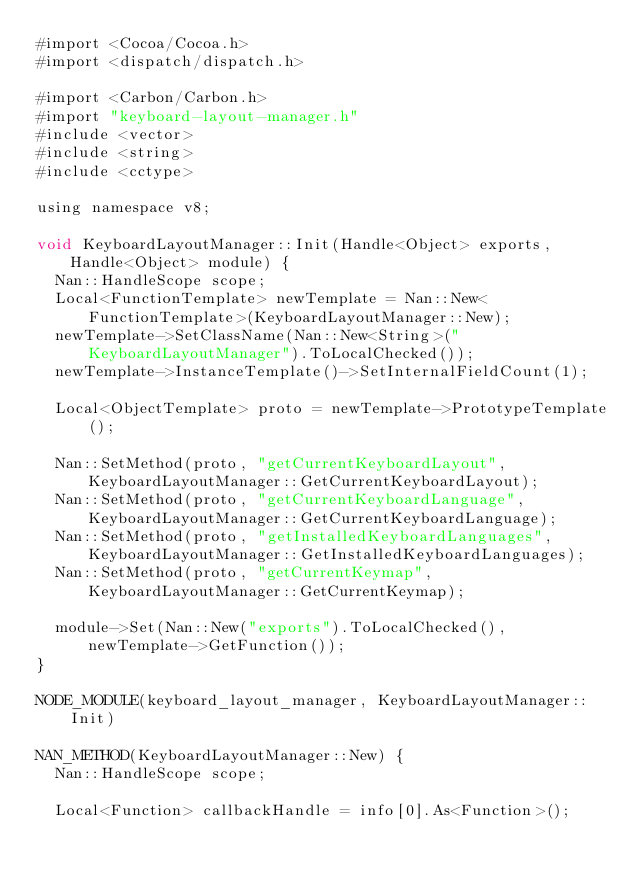Convert code to text. <code><loc_0><loc_0><loc_500><loc_500><_ObjectiveC_>#import <Cocoa/Cocoa.h>
#import <dispatch/dispatch.h>

#import <Carbon/Carbon.h>
#import "keyboard-layout-manager.h"
#include <vector>
#include <string>
#include <cctype>

using namespace v8;

void KeyboardLayoutManager::Init(Handle<Object> exports, Handle<Object> module) {
  Nan::HandleScope scope;
  Local<FunctionTemplate> newTemplate = Nan::New<FunctionTemplate>(KeyboardLayoutManager::New);
  newTemplate->SetClassName(Nan::New<String>("KeyboardLayoutManager").ToLocalChecked());
  newTemplate->InstanceTemplate()->SetInternalFieldCount(1);

  Local<ObjectTemplate> proto = newTemplate->PrototypeTemplate();

  Nan::SetMethod(proto, "getCurrentKeyboardLayout", KeyboardLayoutManager::GetCurrentKeyboardLayout);
  Nan::SetMethod(proto, "getCurrentKeyboardLanguage", KeyboardLayoutManager::GetCurrentKeyboardLanguage);
  Nan::SetMethod(proto, "getInstalledKeyboardLanguages", KeyboardLayoutManager::GetInstalledKeyboardLanguages);
  Nan::SetMethod(proto, "getCurrentKeymap", KeyboardLayoutManager::GetCurrentKeymap);

  module->Set(Nan::New("exports").ToLocalChecked(), newTemplate->GetFunction());
}

NODE_MODULE(keyboard_layout_manager, KeyboardLayoutManager::Init)

NAN_METHOD(KeyboardLayoutManager::New) {
  Nan::HandleScope scope;

  Local<Function> callbackHandle = info[0].As<Function>();</code> 